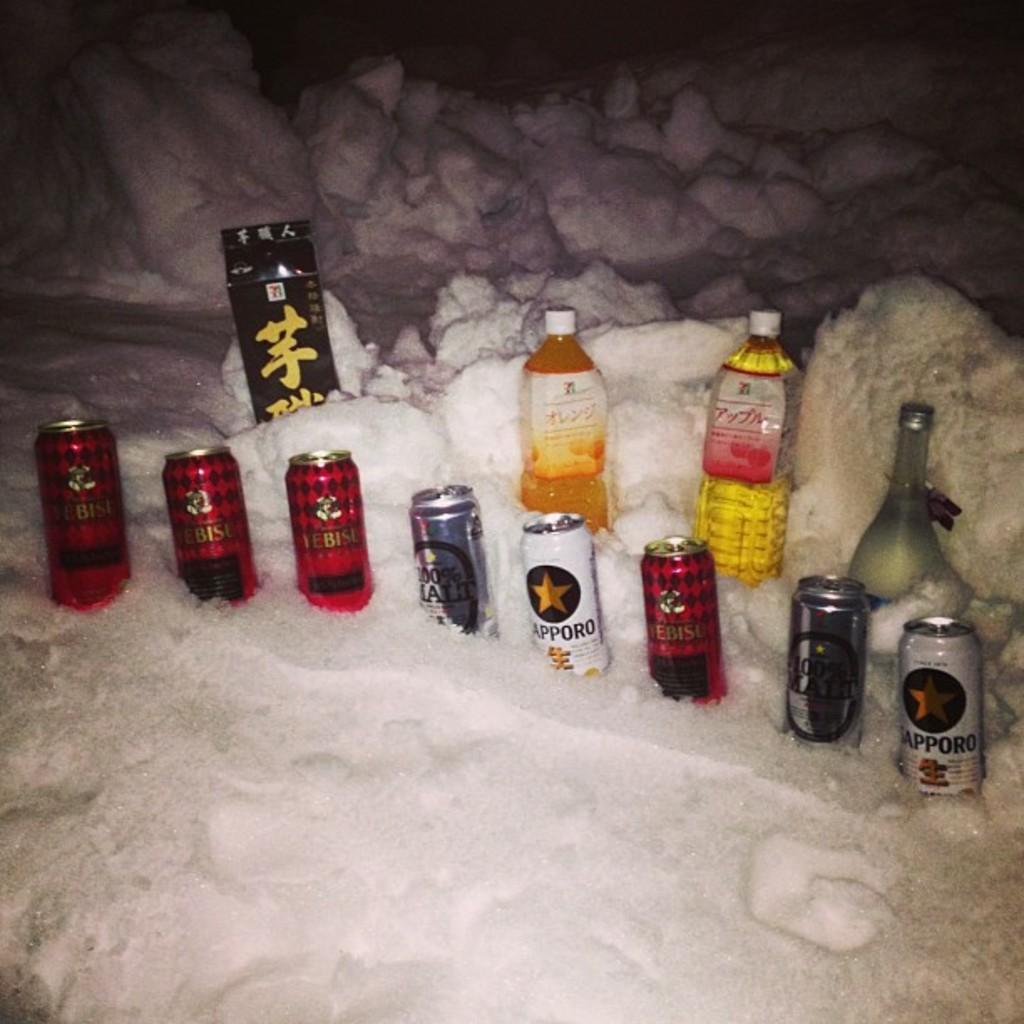What brand is on the red cans?
Provide a short and direct response. Yebisu. 